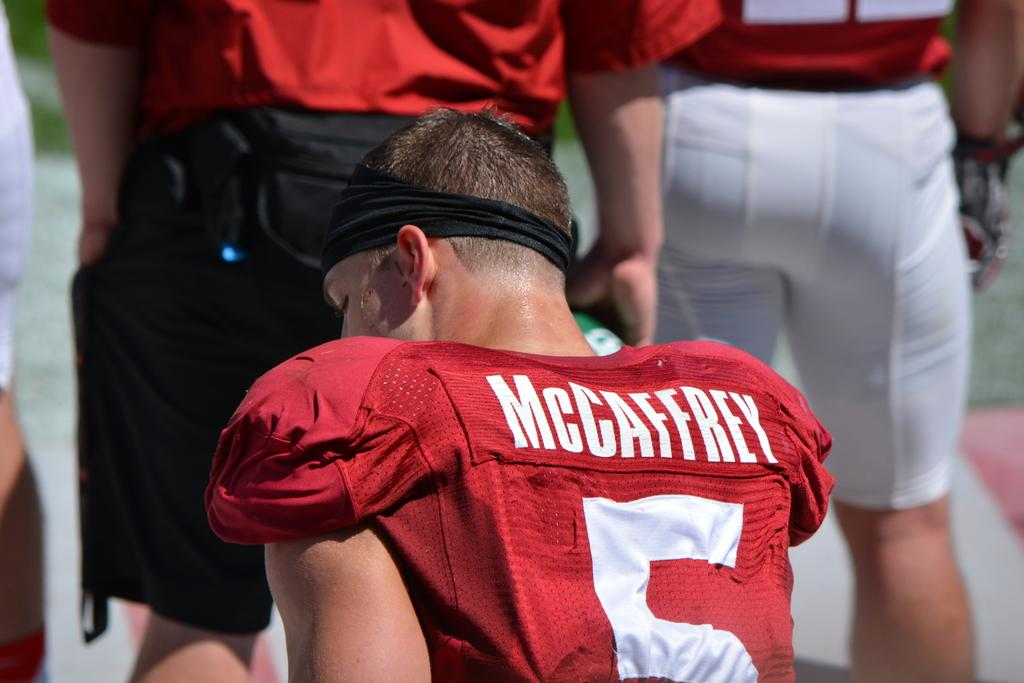<image>
Present a compact description of the photo's key features. McCaffrey sits on the sidelines in his jersey 